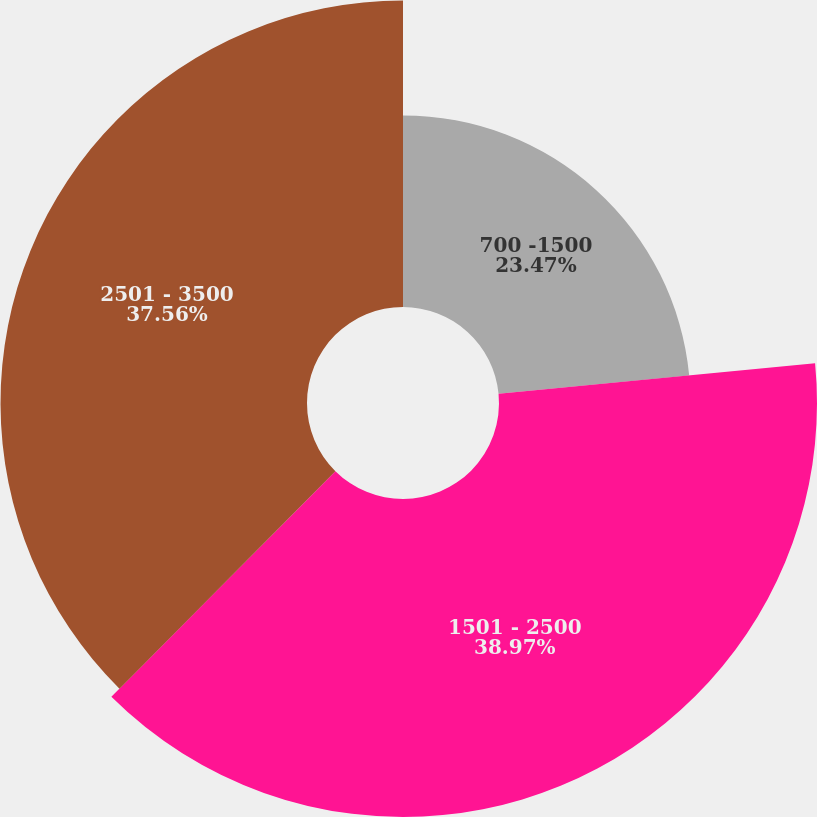Convert chart to OTSL. <chart><loc_0><loc_0><loc_500><loc_500><pie_chart><fcel>700 -1500<fcel>1501 - 2500<fcel>2501 - 3500<nl><fcel>23.47%<fcel>38.97%<fcel>37.56%<nl></chart> 